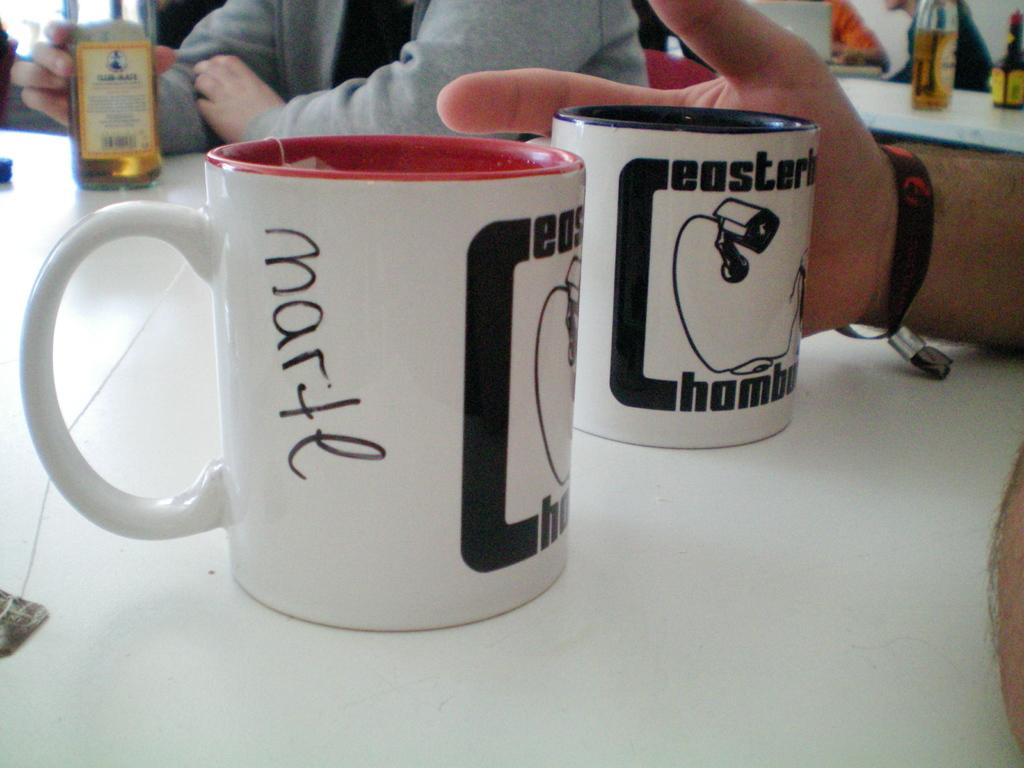<image>
Describe the image concisely. One coffee cup with the name "Marte" written on it sits next to an identical coffee cup. 